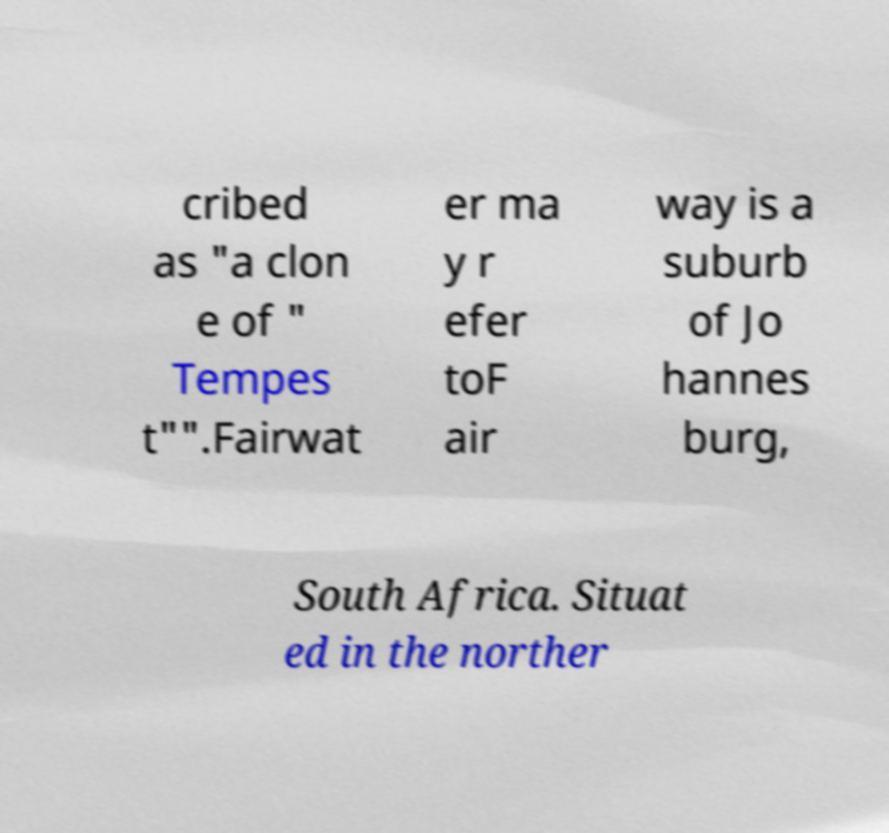What messages or text are displayed in this image? I need them in a readable, typed format. cribed as "a clon e of " Tempes t"".Fairwat er ma y r efer toF air way is a suburb of Jo hannes burg, South Africa. Situat ed in the norther 